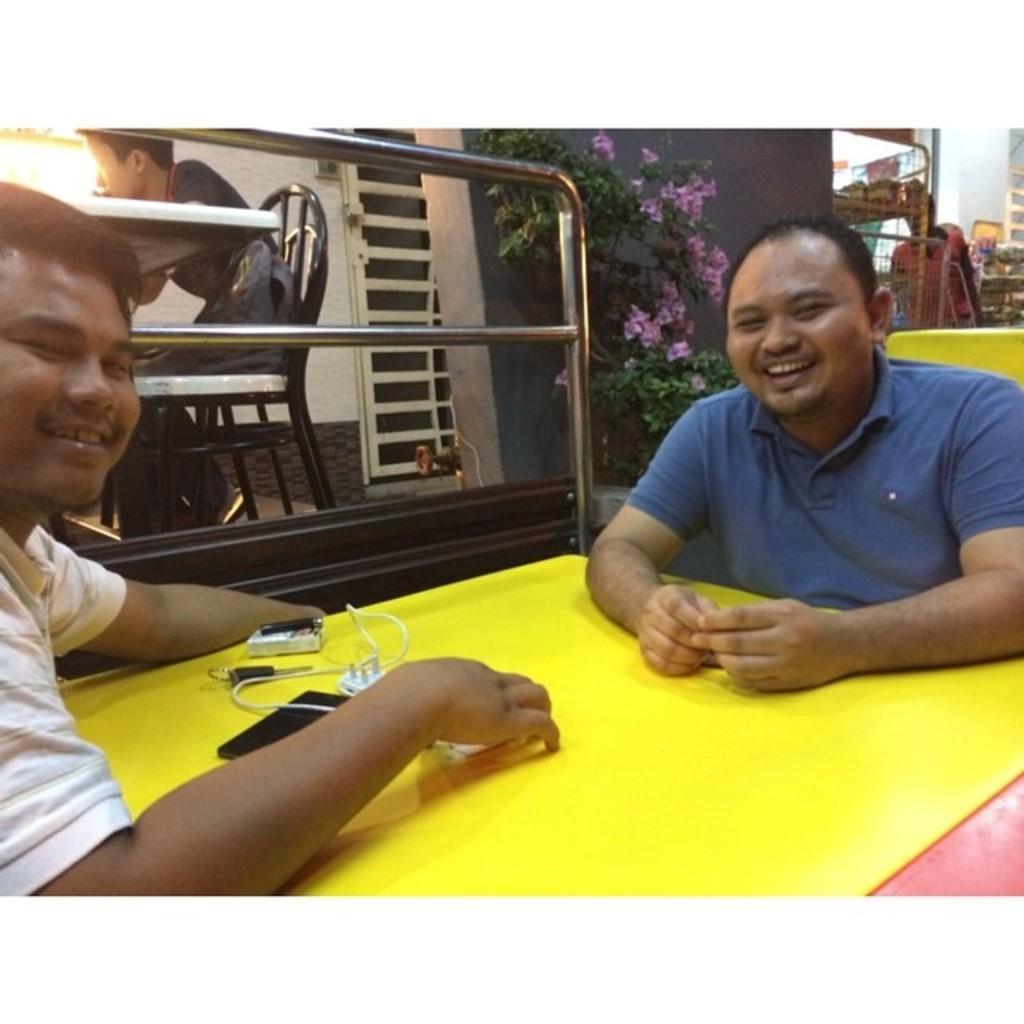In one or two sentences, can you explain what this image depicts? There are two persons sitting around a yellow color table as we can see at the bottom of this image. There is a mobile and other objects are kept on it. We can see a person sitting on a chair and a plant is in the background. 